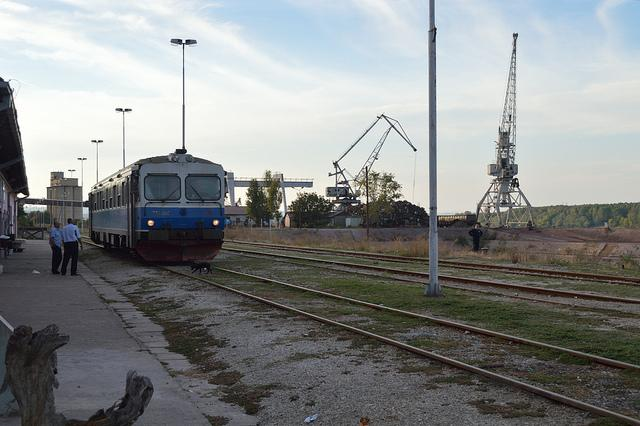Which entity is in the greatest danger?

Choices:
A) dog
B) tall man
C) short man
D) right man dog 